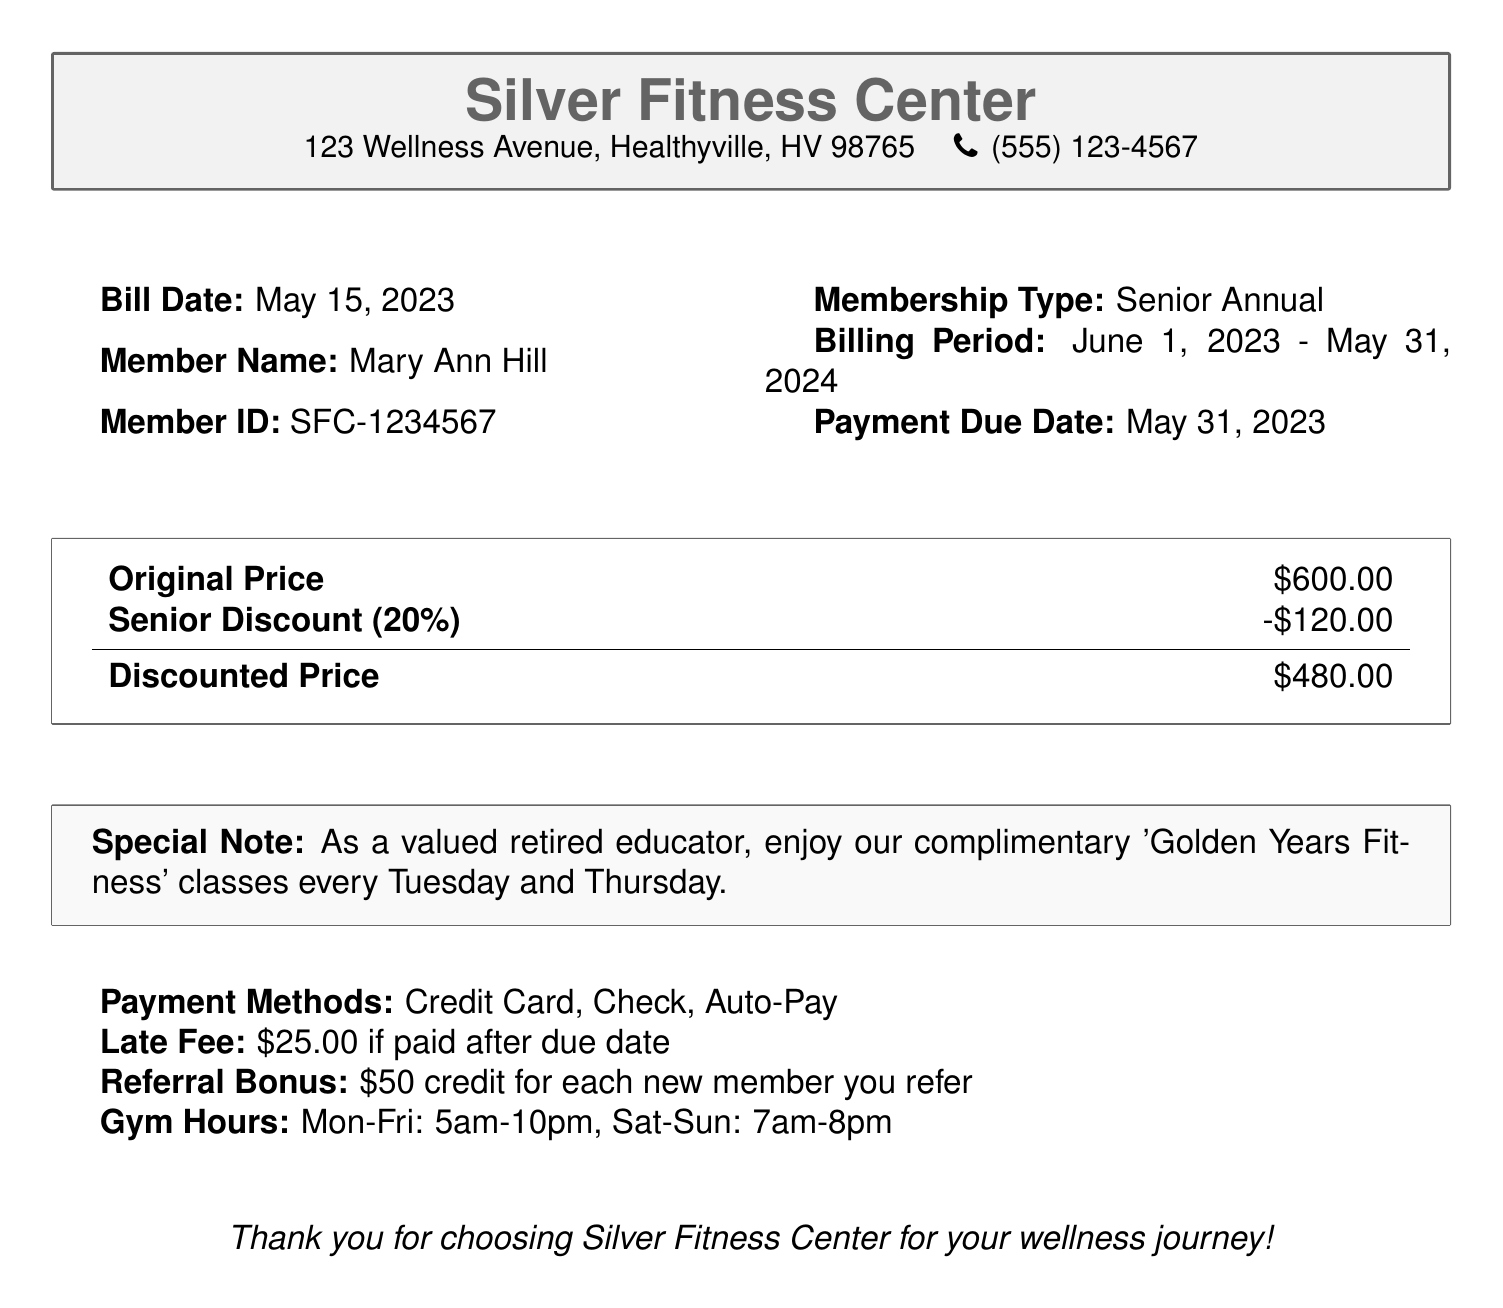What is the bill date? The bill date is stated clearly in the document, which is May 15, 2023.
Answer: May 15, 2023 What is the member ID? The member ID is provided in the document as SFC-1234567.
Answer: SFC-1234567 What is the original price of the membership? The original price mentioned in the document is $600.00.
Answer: $600.00 What is the senior discount percentage? The senior discount percentage indicated in the document is 20%.
Answer: 20% What is the discounted price after applying the senior discount? The discounted price is the result of the original price minus the discount, which is $480.00.
Answer: $480.00 When is the payment due date? The due date for the payment is specified as May 31, 2023.
Answer: May 31, 2023 What is the late fee amount? The document states that the late fee is $25.00 if paid after the due date.
Answer: $25.00 What special benefit is offered to retired educators? The document mentions a complimentary 'Golden Years Fitness' class every Tuesday and Thursday for retired educators.
Answer: 'Golden Years Fitness' classes How can payment be made? The document lists payment methods as Credit Card, Check, or Auto-Pay.
Answer: Credit Card, Check, Auto-Pay What is the referral bonus amount? The referral bonus offered in the document is $50 credit for each new member referred.
Answer: $50 credit 